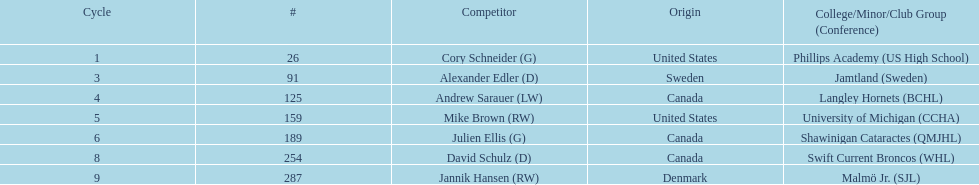How many players were from the united states? 2. 